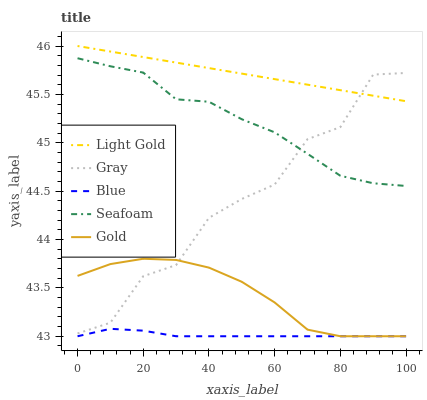Does Blue have the minimum area under the curve?
Answer yes or no. Yes. Does Light Gold have the maximum area under the curve?
Answer yes or no. Yes. Does Gray have the minimum area under the curve?
Answer yes or no. No. Does Gray have the maximum area under the curve?
Answer yes or no. No. Is Light Gold the smoothest?
Answer yes or no. Yes. Is Gray the roughest?
Answer yes or no. Yes. Is Gray the smoothest?
Answer yes or no. No. Is Light Gold the roughest?
Answer yes or no. No. Does Blue have the lowest value?
Answer yes or no. Yes. Does Gray have the lowest value?
Answer yes or no. No. Does Light Gold have the highest value?
Answer yes or no. Yes. Does Gray have the highest value?
Answer yes or no. No. Is Gold less than Light Gold?
Answer yes or no. Yes. Is Gray greater than Blue?
Answer yes or no. Yes. Does Gray intersect Seafoam?
Answer yes or no. Yes. Is Gray less than Seafoam?
Answer yes or no. No. Is Gray greater than Seafoam?
Answer yes or no. No. Does Gold intersect Light Gold?
Answer yes or no. No. 